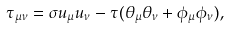Convert formula to latex. <formula><loc_0><loc_0><loc_500><loc_500>\tau _ { \mu \nu } = \sigma u _ { \mu } u _ { \nu } - \tau ( \theta _ { \mu } \theta _ { \nu } + \phi _ { \mu } \phi _ { \nu } ) ,</formula> 